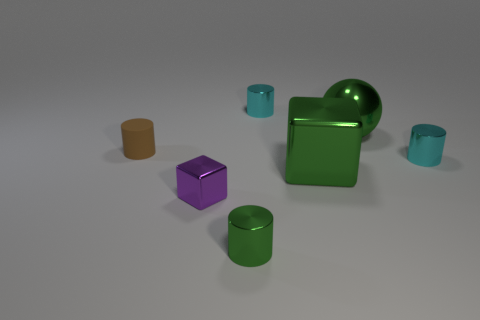What material is the tiny cylinder that is in front of the cyan object in front of the metal cylinder that is behind the brown matte object?
Give a very brief answer. Metal. Is the size of the metal cube right of the purple cube the same as the tiny cube?
Your answer should be compact. No. What is the material of the small green object in front of the small purple thing?
Keep it short and to the point. Metal. Are there more green metal cubes than cyan rubber objects?
Your response must be concise. Yes. How many objects are cylinders that are right of the brown cylinder or small brown metal cylinders?
Your response must be concise. 3. There is a metal cylinder that is in front of the purple metal object; how many small metallic objects are right of it?
Your answer should be very brief. 2. What is the size of the green metal thing in front of the cube that is left of the metal object in front of the purple object?
Offer a terse response. Small. Does the tiny metal cylinder that is in front of the green cube have the same color as the sphere?
Your response must be concise. Yes. What size is the green metal object that is the same shape as the small purple thing?
Offer a very short reply. Large. How many things are cyan metallic objects that are in front of the small brown cylinder or tiny metallic things behind the purple metal block?
Provide a succinct answer. 2. 